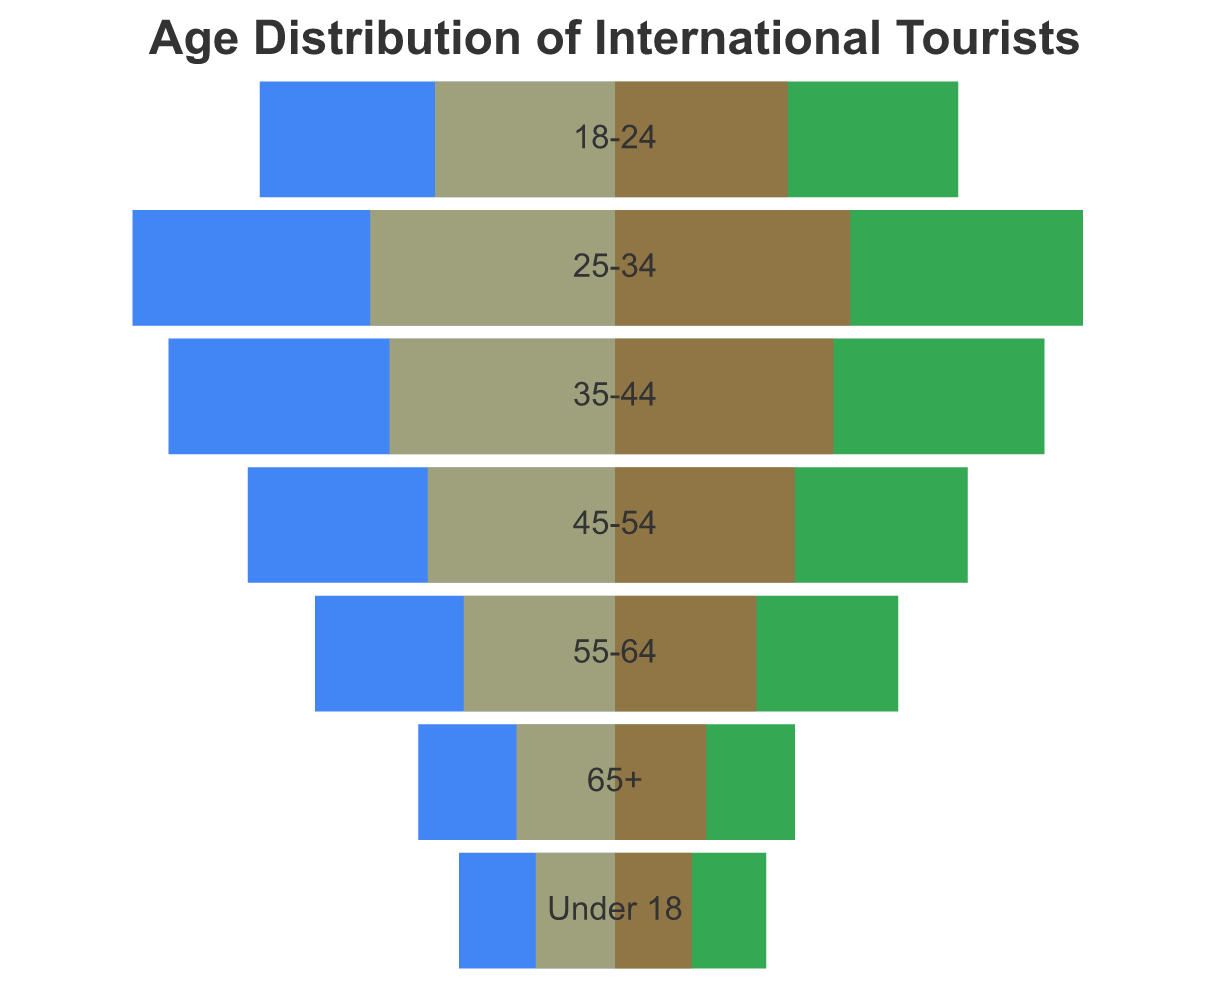How does the age distribution differ between peak and off-peak seasons for tourists aged 65+? Both male and female percentages in the 65+ age group are higher during the peak season compared to the off-peak season. Peak season has males at 8.2% and females at 7.5%, while off-peak season has males at 4.1% and females at 3.8%.
Answer: Higher during peak season What is the most common age group for international tourists during the peak season? By observing the figure, the "25-34" age group has the highest percentage for both males (20.1%) and females (19.5%) during the peak season, making it the most common age group.
Answer: 25-34 By how much does the percentage of male tourists in the 35-44 age group differ between peak and off-peak seasons? The figure shows that the percentage of male tourists in the 35-44 age group is 18.6% during the peak season and 9.4% during the off-peak season. The difference is calculated as 18.6% - 9.4%, which equals 9.2%.
Answer: 9.2% Which gender has a higher percentage in the 45-54 age group during the off-peak season? During the off-peak season, the percentages for the 45-54 age group are 7.8% for males and 7.5% for females. Males have a slightly higher percentage.
Answer: Males Are there more tourists in the "Under 18" age group during the peak season or the off-peak season? For the "Under 18" age group, the peak season percentages are 6.5% for males and 6.3% for females. The off-peak season percentages are 3.3% for males and 3.2% for females. Both male and female percentages are higher during the peak season.
Answer: Peak season What percentage of tourists belong to the 18-24 age group during the peak season? The figure shows the peak season percentages for the 18-24 age group are 14.8% for males and 14.3% for females.
Answer: 14.8% (males), 14.3% (females) Which age group shows the smallest difference in female tourist percentages between peak and off-peak seasons? By comparing the figures, the "18-24" age group has the smallest difference in female tourist percentages between peak (14.3%) and off-peak (7.2%) seasons. The difference is 14.3% - 7.2%, which equals 7.1%.
Answer: 18-24 age group How does the peak season distribution for the "55-64" age group compare to the off-peak season? In the "55-64" age group, peak season percentages are 12.5% for males and 11.8% for females, while off-peak season percentages are 6.3% for males and 5.9% for females. The peak season has higher percentages for both genders.
Answer: Higher in peak season What is the total percentage of female tourists in the 35-44 age group for both peak and off-peak seasons? For the 35-44 age group, the peak season percentage is 17.9% and off-peak season percentage is 9.1%. The total percentage is calculated as 17.9% + 9.1%, which equals 27%.
Answer: 27% Which age group experiences the largest decline in male tourists from peak season to off-peak season? The largest decline can be observed in the "25-34" age group, where the peak season percentage is 20.1% and the off-peak season percentage is 10.2%. The decline is calculated as 20.1% - 10.2%, which equals 9.9%.
Answer: 25-34 